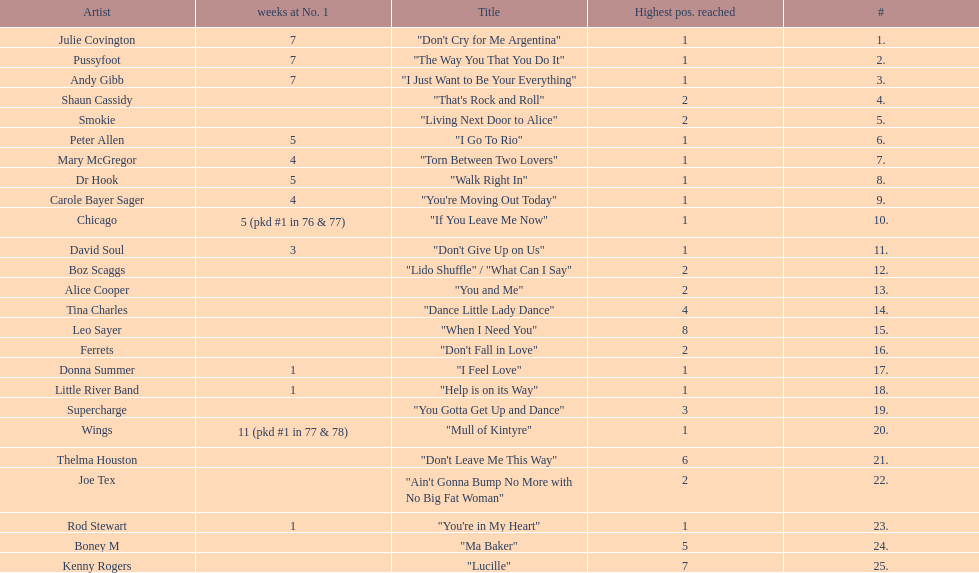How many songs in the table only reached position number 2? 6. 